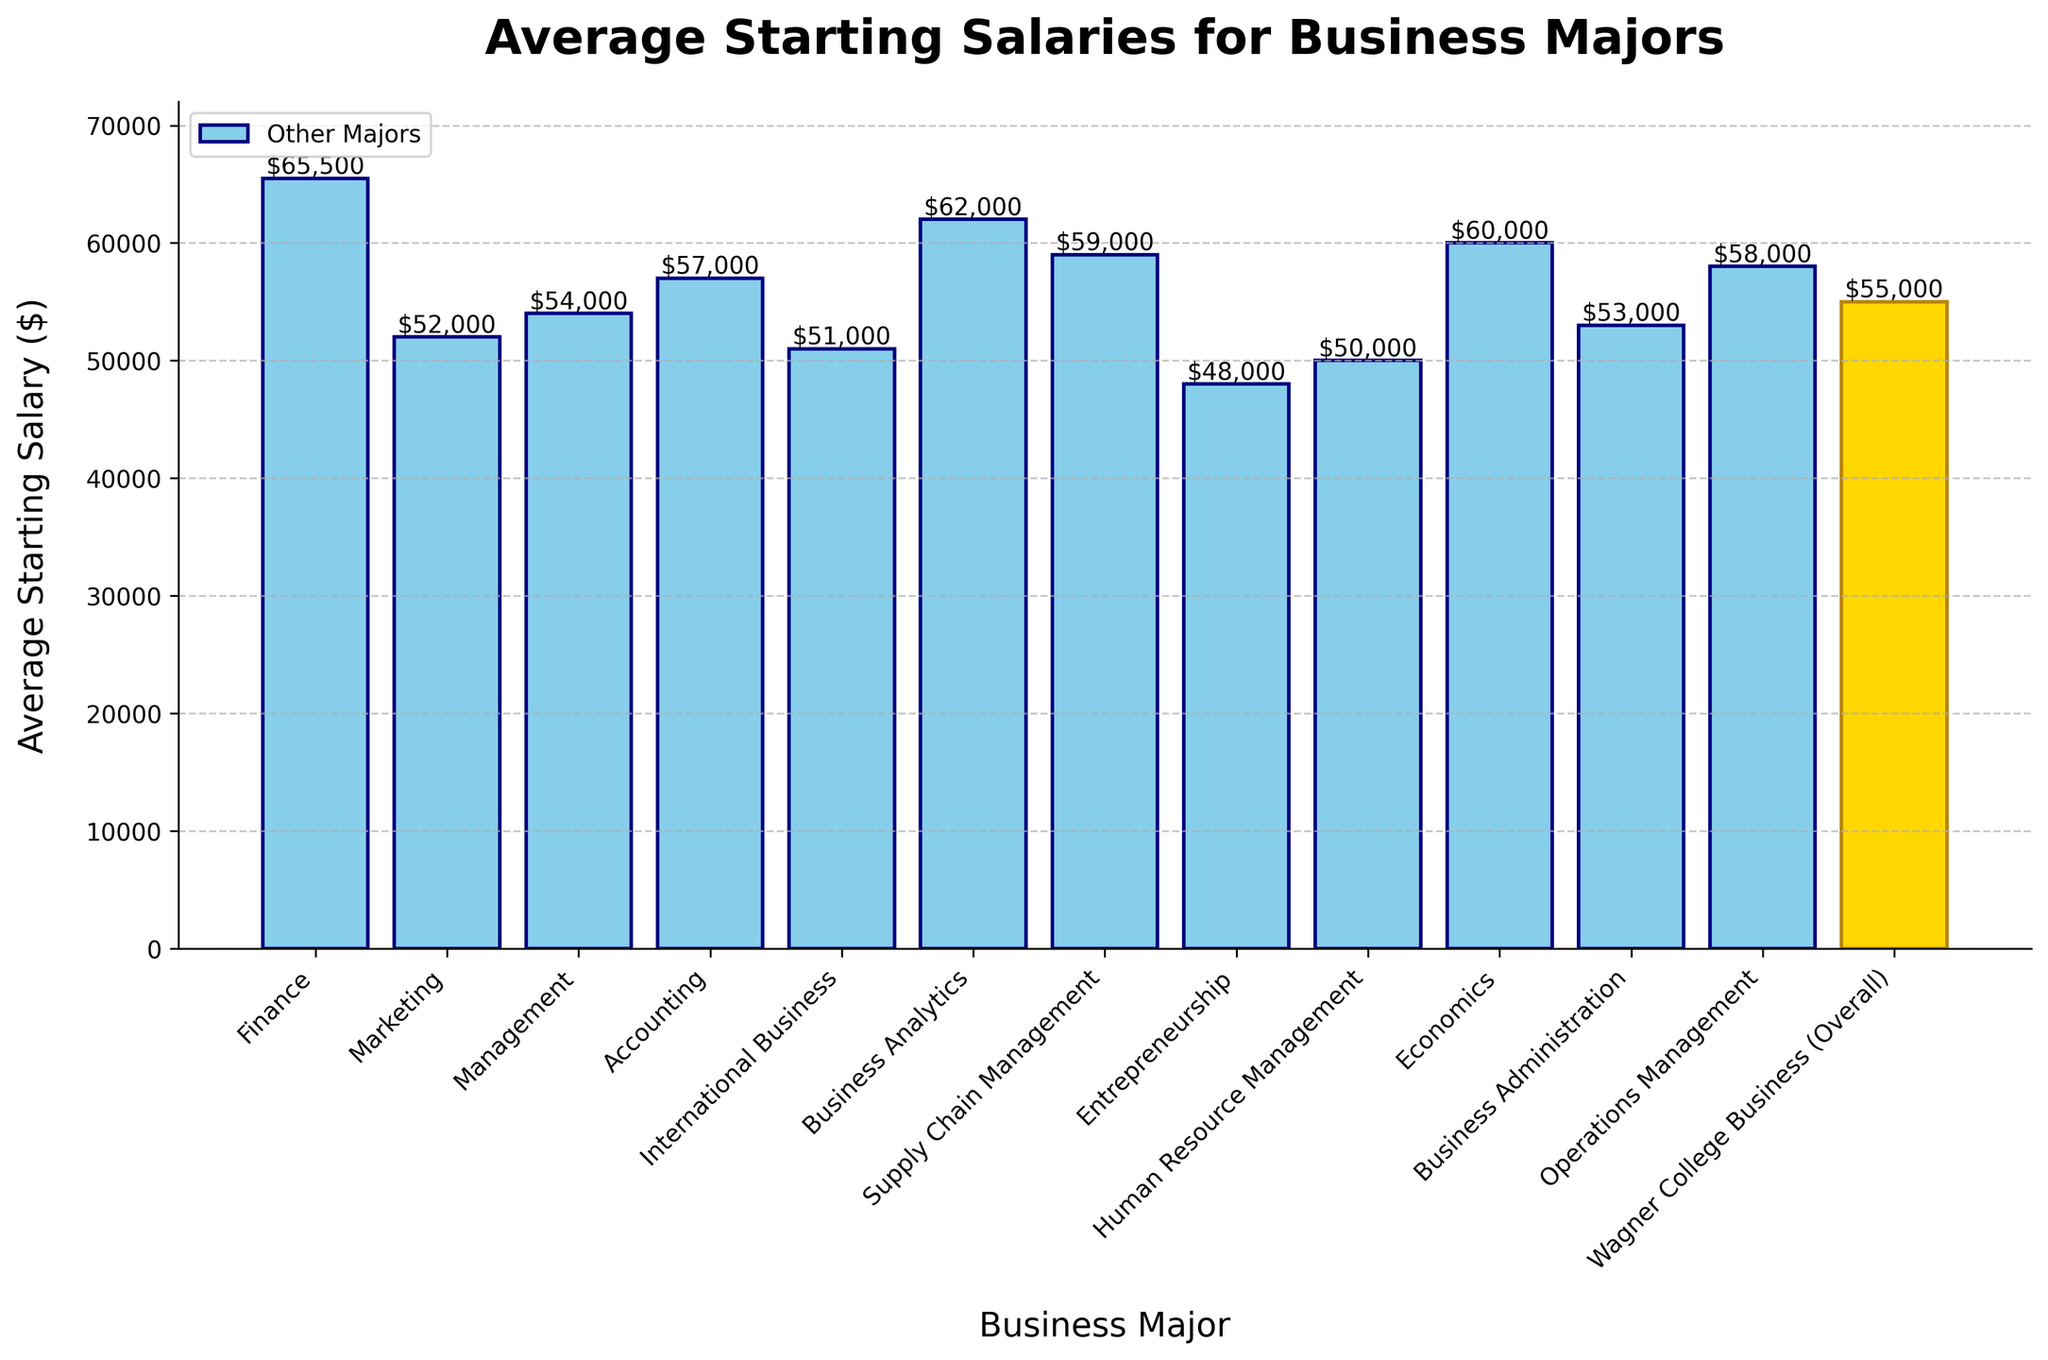Which major has the highest average starting salary? The tallest bar represents the highest average starting salary. By looking at the figure, Finance has the tallest bar.
Answer: Finance Which major has the lowest average starting salary? The shortest bar represents the lowest average starting salary. Entrepreneurship is represented by the shortest bar.
Answer: Entrepreneurship How does the average starting salary of Marketing compare to that of Accounting? Look at the heights of the bars for Marketing and Accounting. The bar for Accounting is taller than the bar for Marketing indicating a higher average starting salary.
Answer: Accounting is higher What is the difference between the highest and lowest average starting salaries among the majors? The highest average starting salary is Finance ($65,500) and the lowest is Entrepreneurship ($48,000). Subtract the lowest from the highest: 65,500 - 48,000.
Answer: $17,500 How does the average starting salary of Wagner College Business (Overall) compare to Business Administration? Find the positions of both bars. Wagner College Business (Overall) bar is $55,000, and Business Administration is $53,000. Wagner College Business is higher.
Answer: Wagner College Business is higher Which major is closest to the average starting salary of Wagner College Business (Overall)? Wagner College Business (Overall) averages $55,000. Look for the bar closest to this value. Management at $54,000 is closest.
Answer: Management Rank the top three majors in terms of average starting salary. Identify the three tallest bars: Finance ($65,500), Business Analytics ($62,000), and Economics ($60,000). Rank them in descending order.
Answer: Finance, Business Analytics, Economics What is the combined average starting salary of Supply Chain Management and International Business? Supply Chain Management averages $59,000 and International Business averages $51,000. Add them together: 59,000 + 51,000.
Answer: $110,000 Which major has the average starting salary closest to the median value of all majors listed? Arrange the salaries in ascending order and find the median. The values are 48,000, 50,000, 51,000, 52,000, 53,000, 54,000, 55,000, 57,000, 58,000, 59,000, 60,000, 62,000, 65,000. The median is $55,000, aligning with Wagner College Business (Overall).
Answer: Wagner College Business (Overall) How does the average starting salary of Human Resource Management compare to International Business? Find the bars for Human Resource Management and International Business. They both stand at $50,000 and $51,000 respectively.
Answer: International Business is higher 